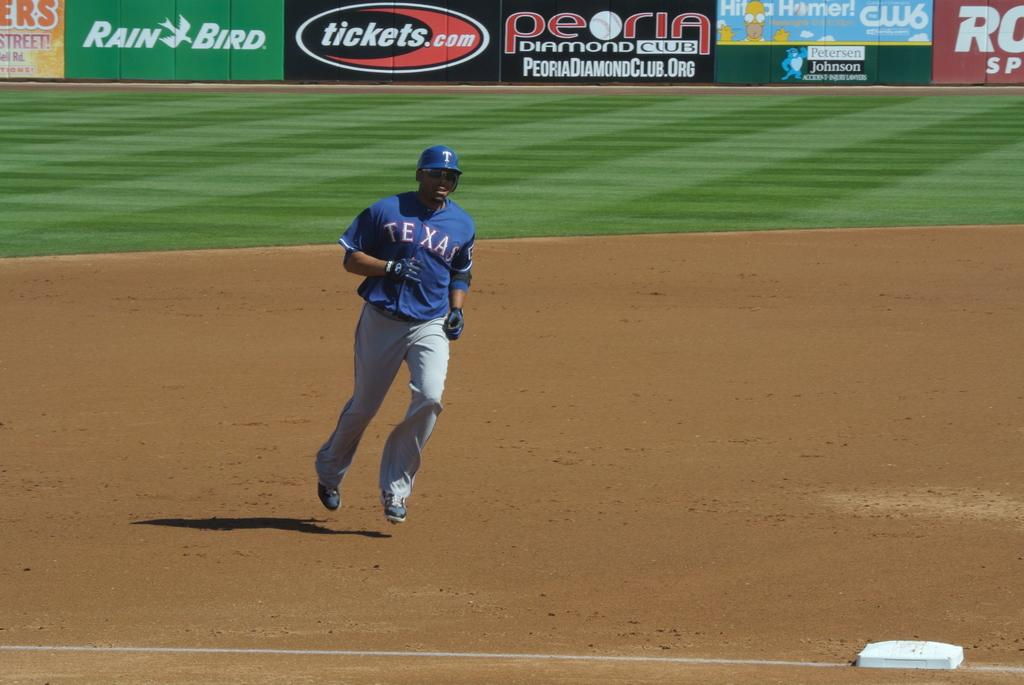<image>
Provide a brief description of the given image. A hitter wearing a Texas jersey is running around the base. 